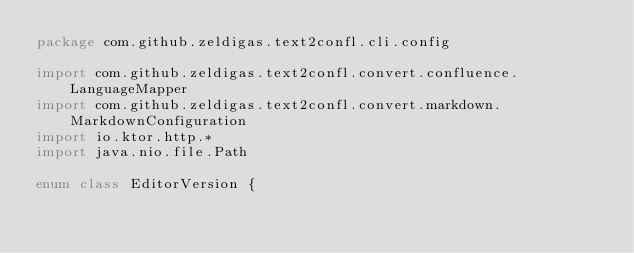<code> <loc_0><loc_0><loc_500><loc_500><_Kotlin_>package com.github.zeldigas.text2confl.cli.config

import com.github.zeldigas.text2confl.convert.confluence.LanguageMapper
import com.github.zeldigas.text2confl.convert.markdown.MarkdownConfiguration
import io.ktor.http.*
import java.nio.file.Path

enum class EditorVersion {</code> 